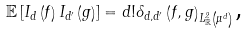<formula> <loc_0><loc_0><loc_500><loc_500>\mathbb { E } \left [ I _ { d } \left ( f \right ) I _ { d ^ { \prime } } \left ( g \right ) \right ] = d ! \delta _ { d , d ^ { \prime } } \left ( f , g \right ) _ { L _ { \mathbb { R } } ^ { 2 } \left ( \mu ^ { d } \right ) } \text {,}</formula> 